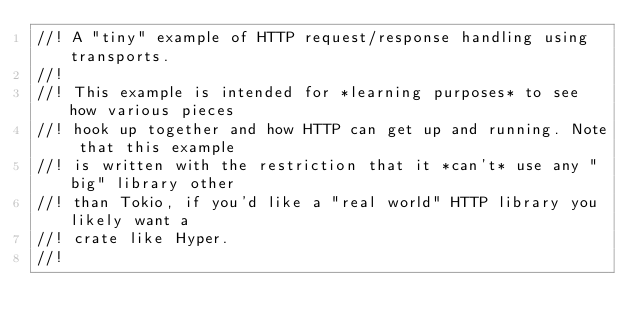Convert code to text. <code><loc_0><loc_0><loc_500><loc_500><_Rust_>//! A "tiny" example of HTTP request/response handling using transports.
//!
//! This example is intended for *learning purposes* to see how various pieces
//! hook up together and how HTTP can get up and running. Note that this example
//! is written with the restriction that it *can't* use any "big" library other
//! than Tokio, if you'd like a "real world" HTTP library you likely want a
//! crate like Hyper.
//!</code> 